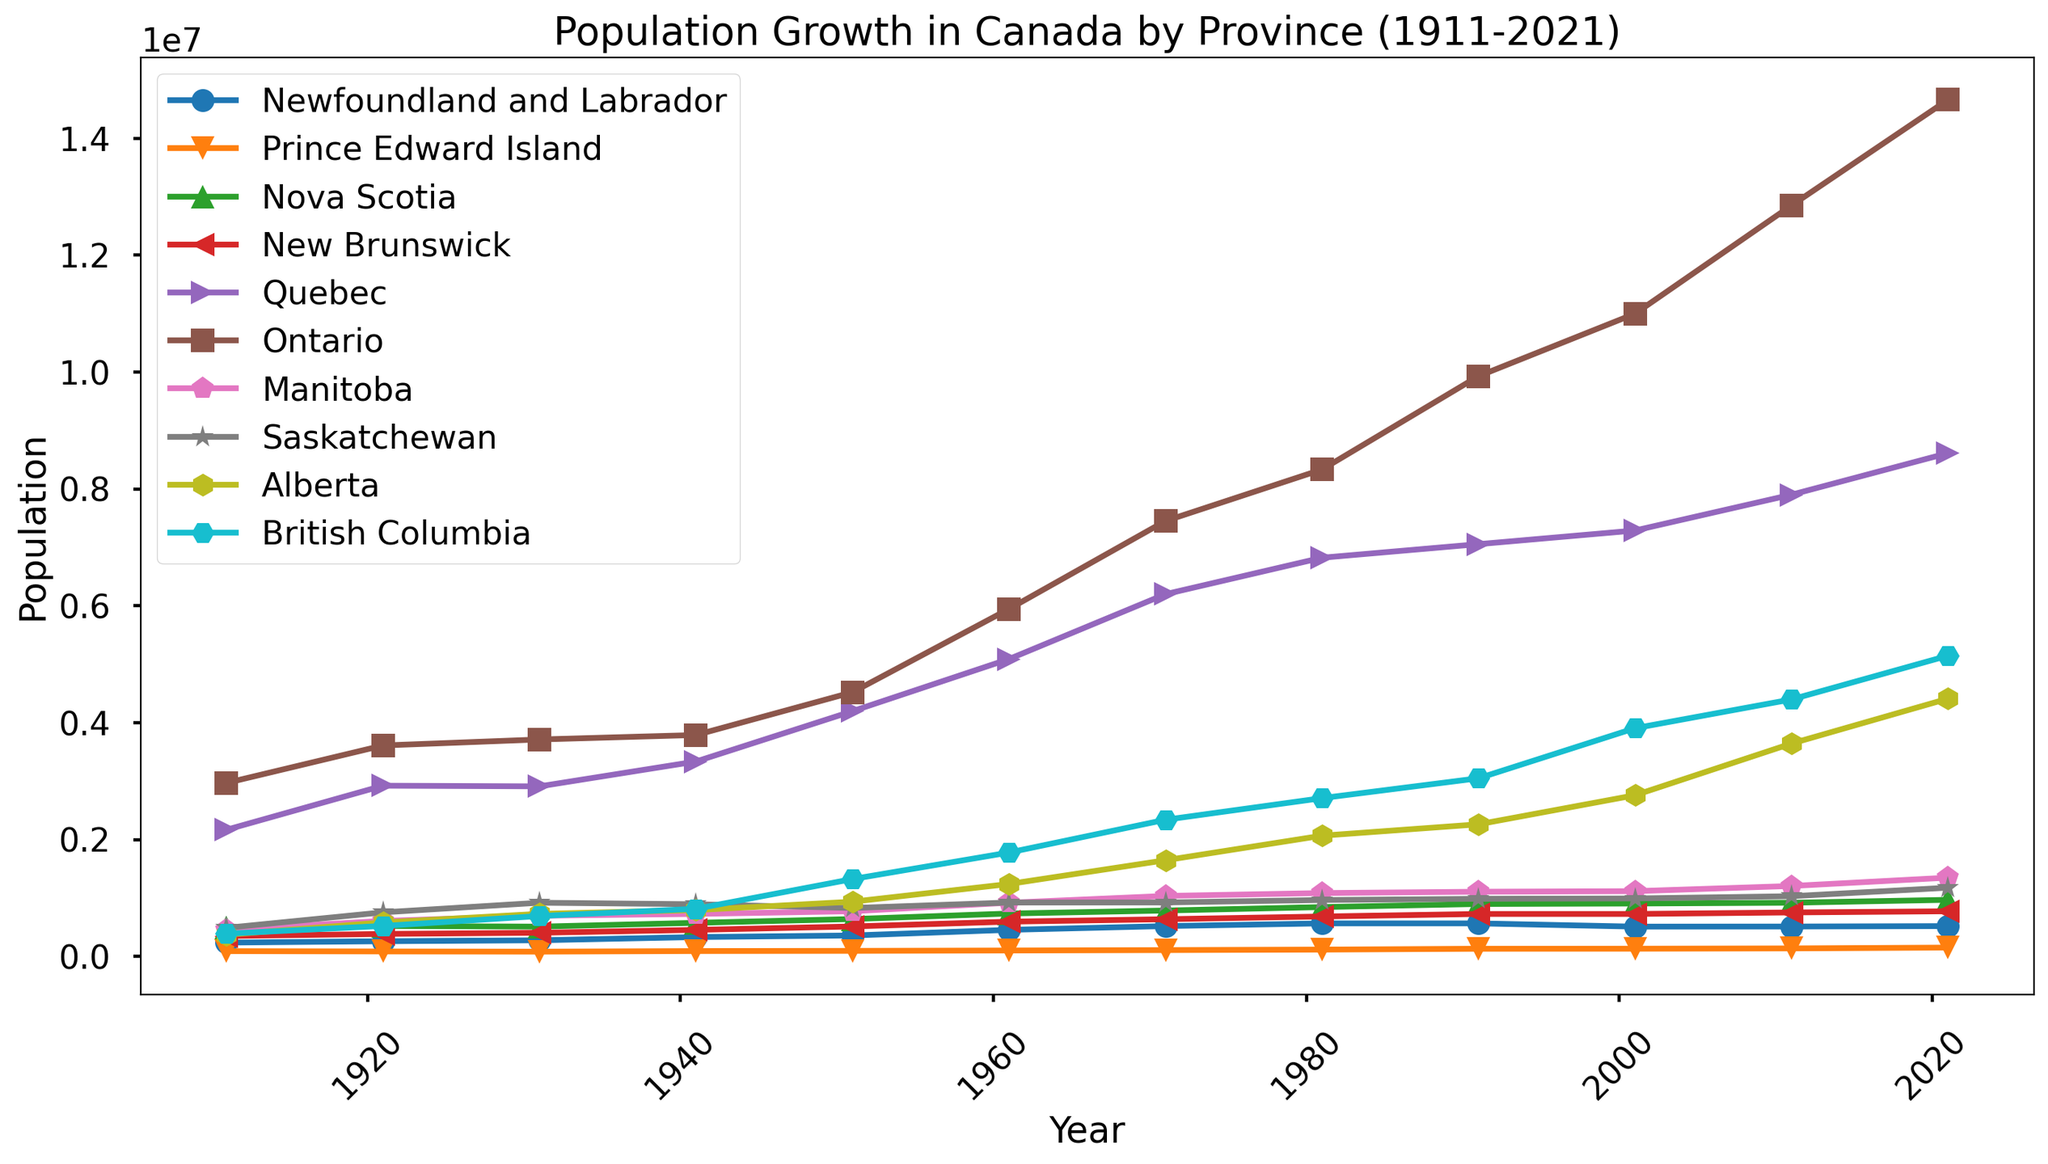What year did Ontario surpass a population of 10 million? By looking at the trend line for Ontario, identify the point at which it crosses the 10 million mark on the y-axis and determine the corresponding year on the x-axis.
Answer: 2001 Which provinces had over 1 million people in 2021? Refer to the figure, and for each province, check the population value in the year 2021 to see if it exceeds 1 million. The provinces with populations over 1 million are Alberta, British Columbia, Manitoba, Ontario, and Quebec.
Answer: Alberta, British Columbia, Manitoba, Ontario, Quebec What is the population difference between Quebec and Alberta in 2021? From the graph, note the population values for Quebec and Alberta in 2021. Then, subtract Alberta's population from Quebec's population to find the difference. Quebec's 2021 population is about 8.6 million, while Alberta's is about 4.4 million. The difference is approximately 4.2 million.
Answer: 4.2 million Which province experienced the highest population growth rate from 1911 to 2021? Compare the population values of each province in 1911 and 2021 by percentage increase. Calculate growth as ((population in 2021 - population in 1911) / population in 1911) * 100%. The province with the highest percentage is the one with the most significant growth rate. Alberta shows the highest growth, rising from approximately 375,000 to 4.4 million.
Answer: Alberta Was the population of Prince Edward Island ever higher than that of Newfoundland and Labrador between 1911 and 2021? Scan the population lines for both provinces across the entire x-axis (1911 to 2021). There is no crossing point where Prince Edward Island's population exceeds that of Newfoundland and Labrador.
Answer: No In which decade did British Columbia see the most significant population increase from a visual inspection? Look at the slope of the population line for British Columbia over each decade. The steepest slope corresponds to the decade with the most significant increase. This appears to be between 1951 and 1961.
Answer: 1951-1961 What is the average population of Nova Scotia across all recorded years? Add Nova Scotia's population for each year and divide by the number of years. For example, add (492338 + 523837 + 512846 + 577962 + 642584 + 737007 + 788165 + 847442 + 899942 + 908007 + 921727 + 971395) and divide by 12. This averages approximately 751,875.
Answer: 751,875 Which two provinces had the least population growth between 1911 and 2021? Calculate the population growth for each province by finding the difference in population between 2021 and 1911 for each province. Compare the values to see which two provinces have the smallest differences. The two provinces are Newfoundland and Labrador, and Prince Edward Island.
Answer: Newfoundland and Labrador, and Prince Edward Island 